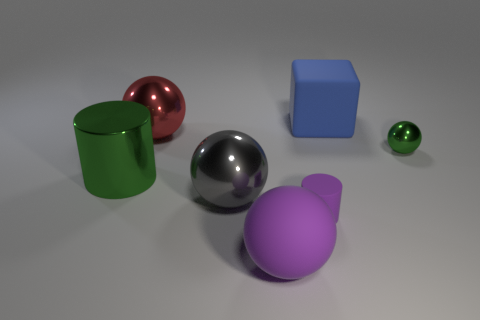What number of objects are tiny purple matte cylinders or large green things?
Give a very brief answer. 2. There is a green thing that is on the left side of the matte object that is behind the green sphere; what shape is it?
Your answer should be compact. Cylinder. There is a tiny thing that is behind the big cylinder; does it have the same shape as the big gray thing?
Provide a succinct answer. Yes. There is a gray sphere that is made of the same material as the red sphere; what is its size?
Provide a short and direct response. Large. How many things are either green shiny objects that are to the left of the small green shiny ball or balls that are to the left of the matte cylinder?
Make the answer very short. 4. Are there the same number of purple matte things behind the purple rubber sphere and gray metallic things behind the big gray metallic sphere?
Your response must be concise. No. There is a cylinder that is left of the red metallic thing; what color is it?
Offer a very short reply. Green. Does the matte ball have the same color as the large matte thing that is behind the purple cylinder?
Provide a short and direct response. No. Are there fewer purple objects than tiny purple cylinders?
Give a very brief answer. No. There is a big sphere that is behind the shiny cylinder; is its color the same as the block?
Ensure brevity in your answer.  No. 